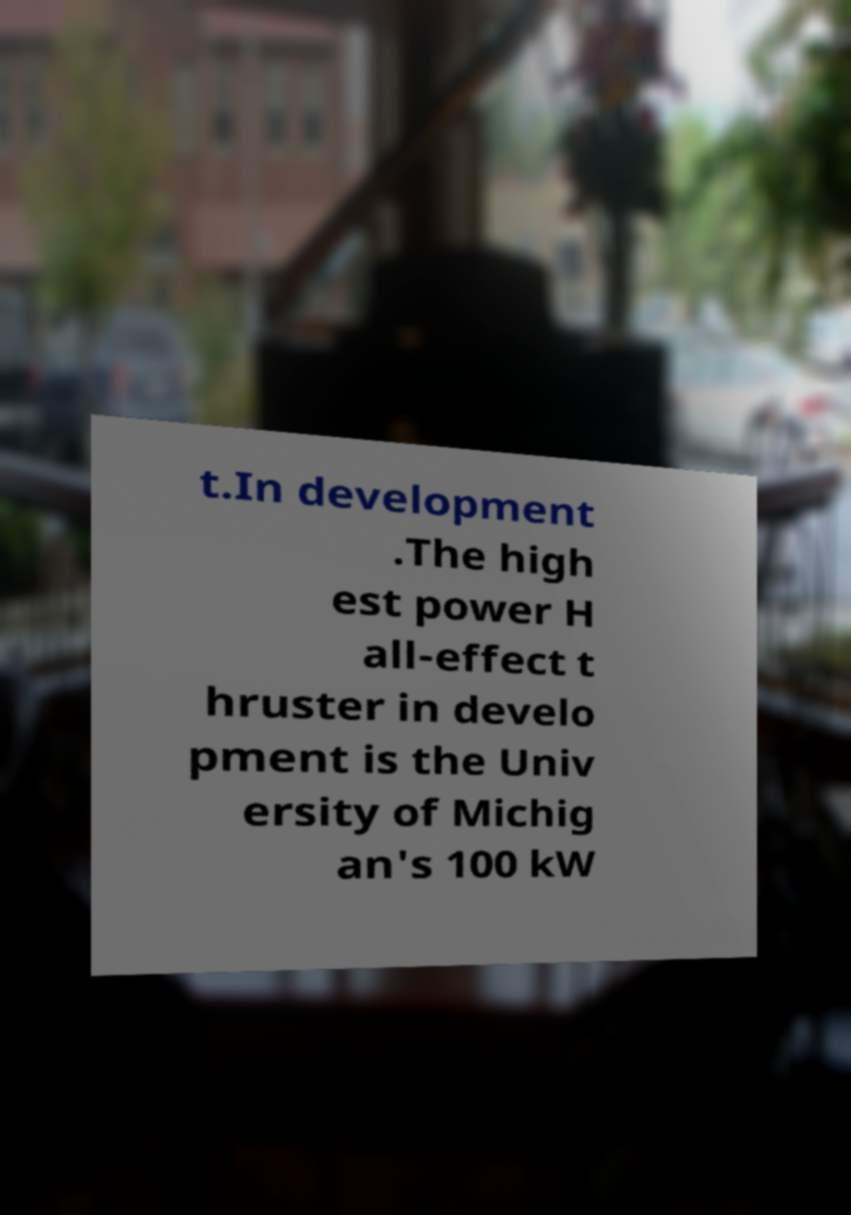What messages or text are displayed in this image? I need them in a readable, typed format. t.In development .The high est power H all-effect t hruster in develo pment is the Univ ersity of Michig an's 100 kW 